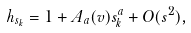<formula> <loc_0><loc_0><loc_500><loc_500>h _ { s _ { k } } = 1 + A _ { a } ( v ) s _ { k } ^ { a } + O ( s ^ { 2 } ) ,</formula> 